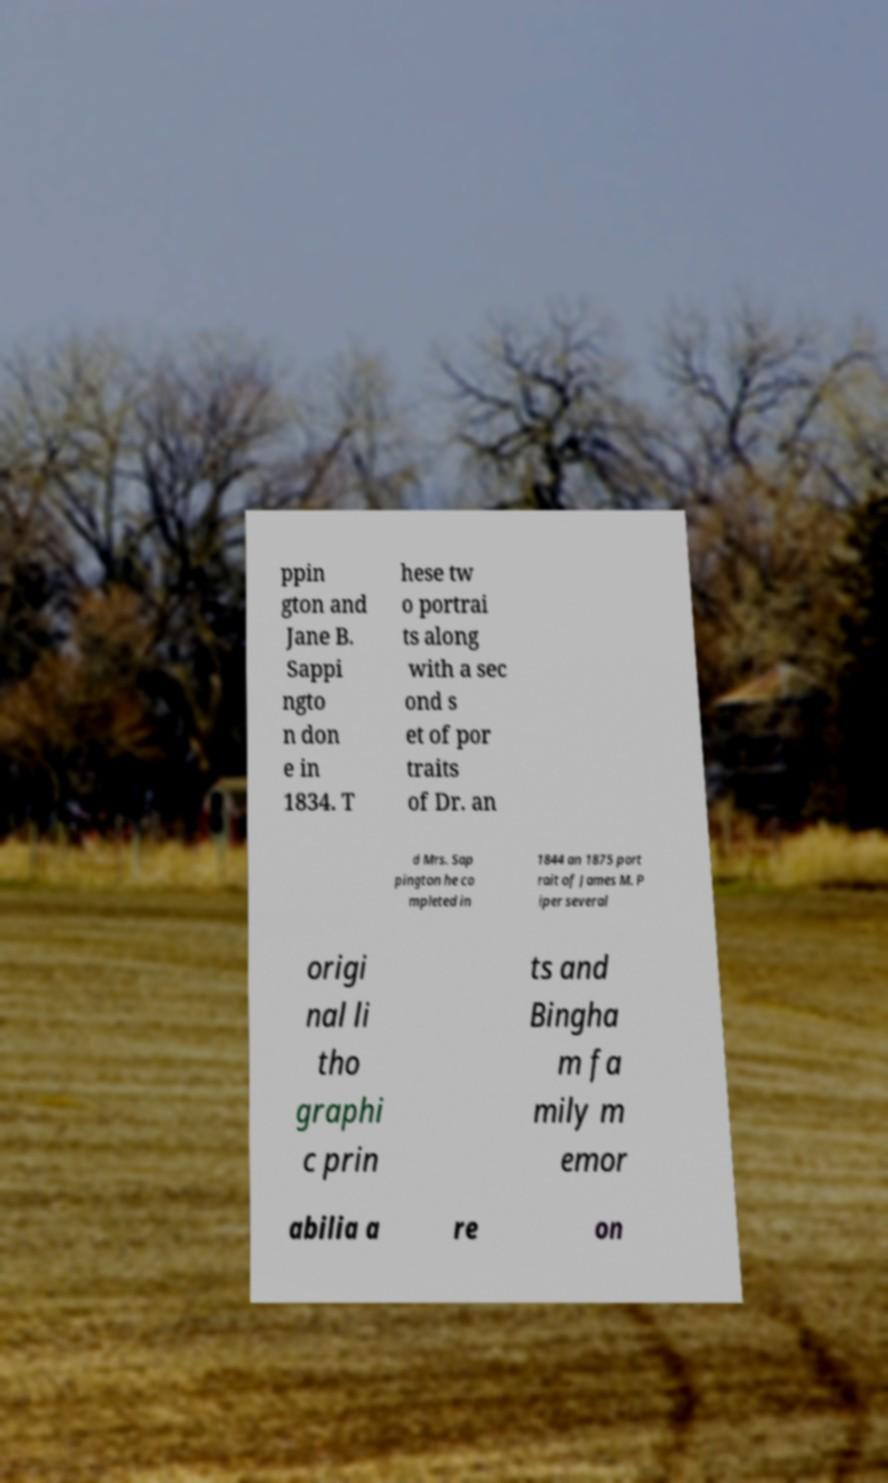What messages or text are displayed in this image? I need them in a readable, typed format. ppin gton and Jane B. Sappi ngto n don e in 1834. T hese tw o portrai ts along with a sec ond s et of por traits of Dr. an d Mrs. Sap pington he co mpleted in 1844 an 1875 port rait of James M. P iper several origi nal li tho graphi c prin ts and Bingha m fa mily m emor abilia a re on 